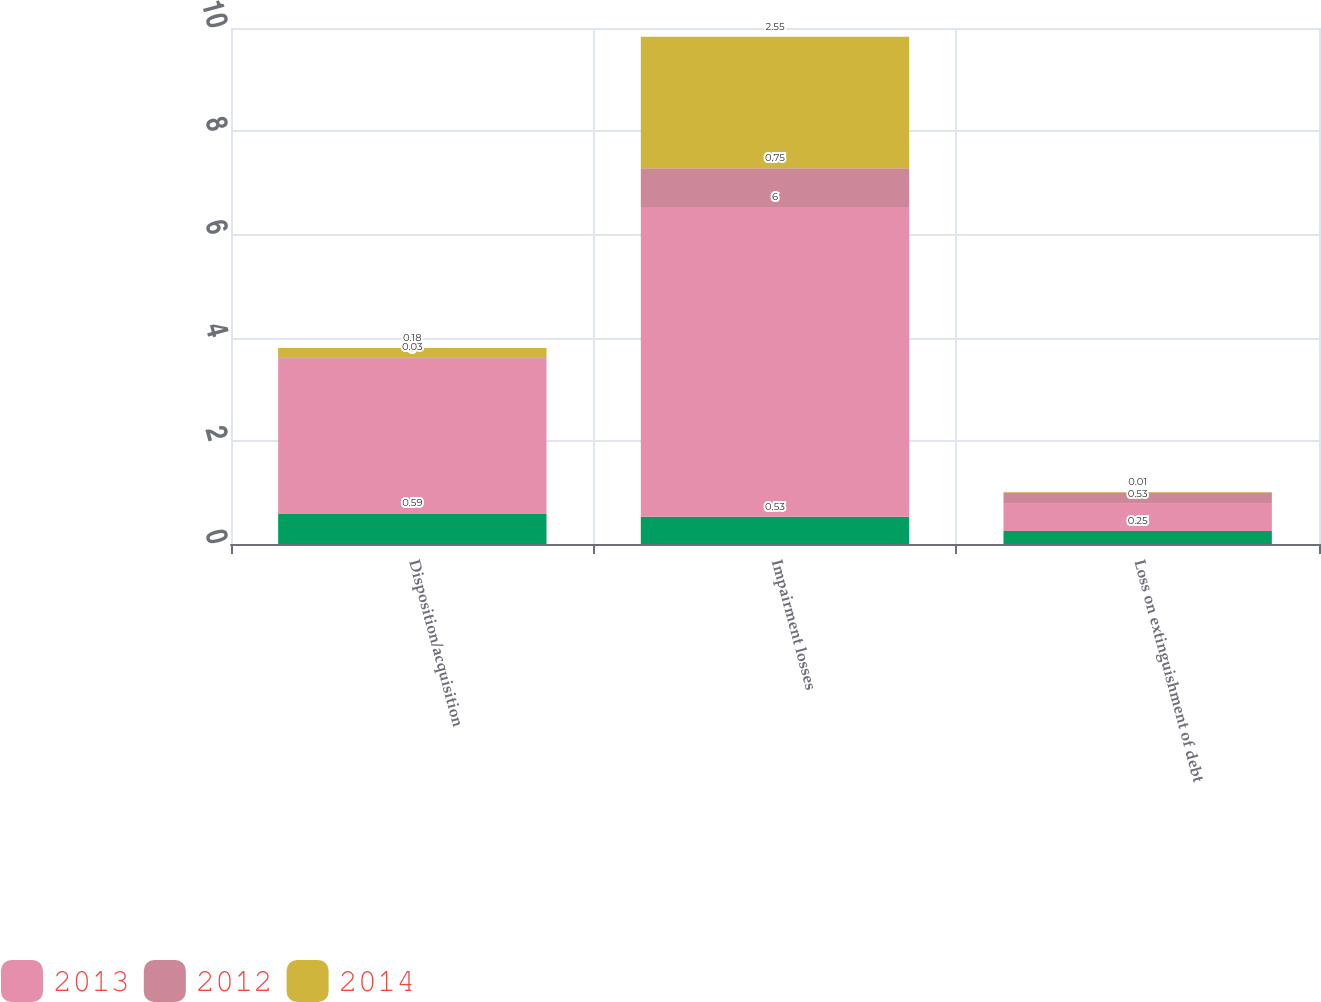Convert chart to OTSL. <chart><loc_0><loc_0><loc_500><loc_500><stacked_bar_chart><ecel><fcel>Disposition/acquisition<fcel>Impairment losses<fcel>Loss on extinguishment of debt<nl><fcel>nan<fcel>0.59<fcel>0.53<fcel>0.25<nl><fcel>2013<fcel>3<fcel>6<fcel>0.53<nl><fcel>2012<fcel>0.03<fcel>0.75<fcel>0.22<nl><fcel>2014<fcel>0.18<fcel>2.55<fcel>0.01<nl></chart> 